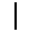<formula> <loc_0><loc_0><loc_500><loc_500>|</formula> 